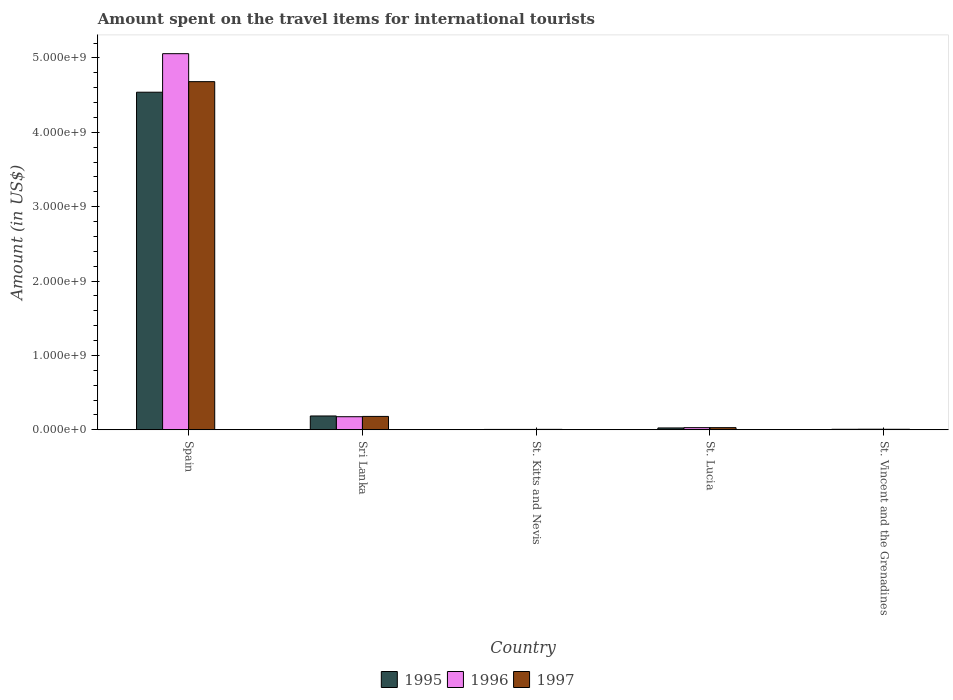How many different coloured bars are there?
Your response must be concise. 3. How many groups of bars are there?
Give a very brief answer. 5. How many bars are there on the 2nd tick from the left?
Make the answer very short. 3. How many bars are there on the 5th tick from the right?
Your response must be concise. 3. What is the label of the 5th group of bars from the left?
Your answer should be very brief. St. Vincent and the Grenadines. In how many cases, is the number of bars for a given country not equal to the number of legend labels?
Provide a short and direct response. 0. What is the amount spent on the travel items for international tourists in 1997 in Spain?
Provide a short and direct response. 4.68e+09. Across all countries, what is the maximum amount spent on the travel items for international tourists in 1995?
Provide a succinct answer. 4.54e+09. Across all countries, what is the minimum amount spent on the travel items for international tourists in 1997?
Your response must be concise. 6.00e+06. In which country was the amount spent on the travel items for international tourists in 1997 maximum?
Your answer should be compact. Spain. In which country was the amount spent on the travel items for international tourists in 1997 minimum?
Your answer should be very brief. St. Kitts and Nevis. What is the total amount spent on the travel items for international tourists in 1997 in the graph?
Ensure brevity in your answer.  4.90e+09. What is the difference between the amount spent on the travel items for international tourists in 1996 in St. Lucia and that in St. Vincent and the Grenadines?
Make the answer very short. 2.10e+07. What is the difference between the amount spent on the travel items for international tourists in 1995 in St. Lucia and the amount spent on the travel items for international tourists in 1996 in Spain?
Provide a short and direct response. -5.03e+09. What is the average amount spent on the travel items for international tourists in 1996 per country?
Your response must be concise. 1.06e+09. What is the difference between the amount spent on the travel items for international tourists of/in 1996 and amount spent on the travel items for international tourists of/in 1995 in Sri Lanka?
Your answer should be very brief. -1.00e+07. What is the ratio of the amount spent on the travel items for international tourists in 1997 in Sri Lanka to that in St. Lucia?
Your answer should be compact. 6.21. What is the difference between the highest and the second highest amount spent on the travel items for international tourists in 1997?
Offer a terse response. 4.50e+09. What is the difference between the highest and the lowest amount spent on the travel items for international tourists in 1996?
Provide a short and direct response. 5.05e+09. In how many countries, is the amount spent on the travel items for international tourists in 1996 greater than the average amount spent on the travel items for international tourists in 1996 taken over all countries?
Keep it short and to the point. 1. Is the sum of the amount spent on the travel items for international tourists in 1997 in St. Lucia and St. Vincent and the Grenadines greater than the maximum amount spent on the travel items for international tourists in 1995 across all countries?
Offer a terse response. No. Are all the bars in the graph horizontal?
Ensure brevity in your answer.  No. How many countries are there in the graph?
Provide a short and direct response. 5. Are the values on the major ticks of Y-axis written in scientific E-notation?
Ensure brevity in your answer.  Yes. Does the graph contain any zero values?
Your answer should be compact. No. How many legend labels are there?
Offer a very short reply. 3. What is the title of the graph?
Give a very brief answer. Amount spent on the travel items for international tourists. Does "1965" appear as one of the legend labels in the graph?
Make the answer very short. No. What is the Amount (in US$) of 1995 in Spain?
Offer a terse response. 4.54e+09. What is the Amount (in US$) of 1996 in Spain?
Provide a succinct answer. 5.06e+09. What is the Amount (in US$) in 1997 in Spain?
Your response must be concise. 4.68e+09. What is the Amount (in US$) in 1995 in Sri Lanka?
Your response must be concise. 1.86e+08. What is the Amount (in US$) of 1996 in Sri Lanka?
Offer a very short reply. 1.76e+08. What is the Amount (in US$) in 1997 in Sri Lanka?
Keep it short and to the point. 1.80e+08. What is the Amount (in US$) of 1995 in St. Kitts and Nevis?
Provide a short and direct response. 5.00e+06. What is the Amount (in US$) in 1996 in St. Kitts and Nevis?
Your response must be concise. 5.00e+06. What is the Amount (in US$) in 1995 in St. Lucia?
Your response must be concise. 2.50e+07. What is the Amount (in US$) of 1996 in St. Lucia?
Provide a succinct answer. 2.90e+07. What is the Amount (in US$) in 1997 in St. Lucia?
Make the answer very short. 2.90e+07. What is the Amount (in US$) in 1995 in St. Vincent and the Grenadines?
Your answer should be very brief. 7.00e+06. What is the Amount (in US$) in 1997 in St. Vincent and the Grenadines?
Offer a very short reply. 7.00e+06. Across all countries, what is the maximum Amount (in US$) in 1995?
Provide a succinct answer. 4.54e+09. Across all countries, what is the maximum Amount (in US$) in 1996?
Provide a succinct answer. 5.06e+09. Across all countries, what is the maximum Amount (in US$) of 1997?
Offer a terse response. 4.68e+09. Across all countries, what is the minimum Amount (in US$) of 1995?
Offer a terse response. 5.00e+06. Across all countries, what is the minimum Amount (in US$) in 1996?
Offer a terse response. 5.00e+06. Across all countries, what is the minimum Amount (in US$) of 1997?
Your response must be concise. 6.00e+06. What is the total Amount (in US$) of 1995 in the graph?
Ensure brevity in your answer.  4.76e+09. What is the total Amount (in US$) in 1996 in the graph?
Provide a short and direct response. 5.28e+09. What is the total Amount (in US$) of 1997 in the graph?
Offer a very short reply. 4.90e+09. What is the difference between the Amount (in US$) in 1995 in Spain and that in Sri Lanka?
Provide a succinct answer. 4.35e+09. What is the difference between the Amount (in US$) of 1996 in Spain and that in Sri Lanka?
Provide a succinct answer. 4.88e+09. What is the difference between the Amount (in US$) of 1997 in Spain and that in Sri Lanka?
Give a very brief answer. 4.50e+09. What is the difference between the Amount (in US$) of 1995 in Spain and that in St. Kitts and Nevis?
Give a very brief answer. 4.53e+09. What is the difference between the Amount (in US$) of 1996 in Spain and that in St. Kitts and Nevis?
Ensure brevity in your answer.  5.05e+09. What is the difference between the Amount (in US$) of 1997 in Spain and that in St. Kitts and Nevis?
Provide a short and direct response. 4.68e+09. What is the difference between the Amount (in US$) in 1995 in Spain and that in St. Lucia?
Provide a short and direct response. 4.51e+09. What is the difference between the Amount (in US$) of 1996 in Spain and that in St. Lucia?
Keep it short and to the point. 5.03e+09. What is the difference between the Amount (in US$) of 1997 in Spain and that in St. Lucia?
Your answer should be compact. 4.65e+09. What is the difference between the Amount (in US$) in 1995 in Spain and that in St. Vincent and the Grenadines?
Your answer should be compact. 4.53e+09. What is the difference between the Amount (in US$) of 1996 in Spain and that in St. Vincent and the Grenadines?
Provide a succinct answer. 5.05e+09. What is the difference between the Amount (in US$) of 1997 in Spain and that in St. Vincent and the Grenadines?
Your answer should be very brief. 4.67e+09. What is the difference between the Amount (in US$) of 1995 in Sri Lanka and that in St. Kitts and Nevis?
Ensure brevity in your answer.  1.81e+08. What is the difference between the Amount (in US$) in 1996 in Sri Lanka and that in St. Kitts and Nevis?
Make the answer very short. 1.71e+08. What is the difference between the Amount (in US$) in 1997 in Sri Lanka and that in St. Kitts and Nevis?
Make the answer very short. 1.74e+08. What is the difference between the Amount (in US$) of 1995 in Sri Lanka and that in St. Lucia?
Your answer should be very brief. 1.61e+08. What is the difference between the Amount (in US$) of 1996 in Sri Lanka and that in St. Lucia?
Your answer should be very brief. 1.47e+08. What is the difference between the Amount (in US$) of 1997 in Sri Lanka and that in St. Lucia?
Provide a short and direct response. 1.51e+08. What is the difference between the Amount (in US$) of 1995 in Sri Lanka and that in St. Vincent and the Grenadines?
Your response must be concise. 1.79e+08. What is the difference between the Amount (in US$) in 1996 in Sri Lanka and that in St. Vincent and the Grenadines?
Your answer should be compact. 1.68e+08. What is the difference between the Amount (in US$) of 1997 in Sri Lanka and that in St. Vincent and the Grenadines?
Ensure brevity in your answer.  1.73e+08. What is the difference between the Amount (in US$) in 1995 in St. Kitts and Nevis and that in St. Lucia?
Offer a very short reply. -2.00e+07. What is the difference between the Amount (in US$) of 1996 in St. Kitts and Nevis and that in St. Lucia?
Your answer should be very brief. -2.40e+07. What is the difference between the Amount (in US$) in 1997 in St. Kitts and Nevis and that in St. Lucia?
Provide a short and direct response. -2.30e+07. What is the difference between the Amount (in US$) in 1996 in St. Kitts and Nevis and that in St. Vincent and the Grenadines?
Your response must be concise. -3.00e+06. What is the difference between the Amount (in US$) of 1997 in St. Kitts and Nevis and that in St. Vincent and the Grenadines?
Offer a terse response. -1.00e+06. What is the difference between the Amount (in US$) of 1995 in St. Lucia and that in St. Vincent and the Grenadines?
Provide a succinct answer. 1.80e+07. What is the difference between the Amount (in US$) in 1996 in St. Lucia and that in St. Vincent and the Grenadines?
Keep it short and to the point. 2.10e+07. What is the difference between the Amount (in US$) of 1997 in St. Lucia and that in St. Vincent and the Grenadines?
Offer a terse response. 2.20e+07. What is the difference between the Amount (in US$) of 1995 in Spain and the Amount (in US$) of 1996 in Sri Lanka?
Your answer should be very brief. 4.36e+09. What is the difference between the Amount (in US$) of 1995 in Spain and the Amount (in US$) of 1997 in Sri Lanka?
Make the answer very short. 4.36e+09. What is the difference between the Amount (in US$) in 1996 in Spain and the Amount (in US$) in 1997 in Sri Lanka?
Your answer should be very brief. 4.88e+09. What is the difference between the Amount (in US$) in 1995 in Spain and the Amount (in US$) in 1996 in St. Kitts and Nevis?
Provide a succinct answer. 4.53e+09. What is the difference between the Amount (in US$) of 1995 in Spain and the Amount (in US$) of 1997 in St. Kitts and Nevis?
Ensure brevity in your answer.  4.53e+09. What is the difference between the Amount (in US$) in 1996 in Spain and the Amount (in US$) in 1997 in St. Kitts and Nevis?
Offer a terse response. 5.05e+09. What is the difference between the Amount (in US$) in 1995 in Spain and the Amount (in US$) in 1996 in St. Lucia?
Make the answer very short. 4.51e+09. What is the difference between the Amount (in US$) of 1995 in Spain and the Amount (in US$) of 1997 in St. Lucia?
Ensure brevity in your answer.  4.51e+09. What is the difference between the Amount (in US$) in 1996 in Spain and the Amount (in US$) in 1997 in St. Lucia?
Make the answer very short. 5.03e+09. What is the difference between the Amount (in US$) of 1995 in Spain and the Amount (in US$) of 1996 in St. Vincent and the Grenadines?
Your answer should be very brief. 4.53e+09. What is the difference between the Amount (in US$) in 1995 in Spain and the Amount (in US$) in 1997 in St. Vincent and the Grenadines?
Offer a very short reply. 4.53e+09. What is the difference between the Amount (in US$) in 1996 in Spain and the Amount (in US$) in 1997 in St. Vincent and the Grenadines?
Your response must be concise. 5.05e+09. What is the difference between the Amount (in US$) in 1995 in Sri Lanka and the Amount (in US$) in 1996 in St. Kitts and Nevis?
Offer a terse response. 1.81e+08. What is the difference between the Amount (in US$) in 1995 in Sri Lanka and the Amount (in US$) in 1997 in St. Kitts and Nevis?
Ensure brevity in your answer.  1.80e+08. What is the difference between the Amount (in US$) of 1996 in Sri Lanka and the Amount (in US$) of 1997 in St. Kitts and Nevis?
Your answer should be very brief. 1.70e+08. What is the difference between the Amount (in US$) of 1995 in Sri Lanka and the Amount (in US$) of 1996 in St. Lucia?
Your answer should be compact. 1.57e+08. What is the difference between the Amount (in US$) of 1995 in Sri Lanka and the Amount (in US$) of 1997 in St. Lucia?
Give a very brief answer. 1.57e+08. What is the difference between the Amount (in US$) of 1996 in Sri Lanka and the Amount (in US$) of 1997 in St. Lucia?
Make the answer very short. 1.47e+08. What is the difference between the Amount (in US$) of 1995 in Sri Lanka and the Amount (in US$) of 1996 in St. Vincent and the Grenadines?
Your answer should be very brief. 1.78e+08. What is the difference between the Amount (in US$) of 1995 in Sri Lanka and the Amount (in US$) of 1997 in St. Vincent and the Grenadines?
Make the answer very short. 1.79e+08. What is the difference between the Amount (in US$) in 1996 in Sri Lanka and the Amount (in US$) in 1997 in St. Vincent and the Grenadines?
Offer a very short reply. 1.69e+08. What is the difference between the Amount (in US$) in 1995 in St. Kitts and Nevis and the Amount (in US$) in 1996 in St. Lucia?
Provide a succinct answer. -2.40e+07. What is the difference between the Amount (in US$) of 1995 in St. Kitts and Nevis and the Amount (in US$) of 1997 in St. Lucia?
Offer a very short reply. -2.40e+07. What is the difference between the Amount (in US$) of 1996 in St. Kitts and Nevis and the Amount (in US$) of 1997 in St. Lucia?
Your answer should be compact. -2.40e+07. What is the difference between the Amount (in US$) of 1995 in St. Lucia and the Amount (in US$) of 1996 in St. Vincent and the Grenadines?
Keep it short and to the point. 1.70e+07. What is the difference between the Amount (in US$) of 1995 in St. Lucia and the Amount (in US$) of 1997 in St. Vincent and the Grenadines?
Your answer should be very brief. 1.80e+07. What is the difference between the Amount (in US$) in 1996 in St. Lucia and the Amount (in US$) in 1997 in St. Vincent and the Grenadines?
Your answer should be compact. 2.20e+07. What is the average Amount (in US$) of 1995 per country?
Your answer should be compact. 9.52e+08. What is the average Amount (in US$) of 1996 per country?
Offer a very short reply. 1.06e+09. What is the average Amount (in US$) of 1997 per country?
Provide a short and direct response. 9.81e+08. What is the difference between the Amount (in US$) in 1995 and Amount (in US$) in 1996 in Spain?
Provide a succinct answer. -5.18e+08. What is the difference between the Amount (in US$) of 1995 and Amount (in US$) of 1997 in Spain?
Your answer should be very brief. -1.42e+08. What is the difference between the Amount (in US$) of 1996 and Amount (in US$) of 1997 in Spain?
Your answer should be compact. 3.76e+08. What is the difference between the Amount (in US$) in 1995 and Amount (in US$) in 1996 in Sri Lanka?
Ensure brevity in your answer.  1.00e+07. What is the difference between the Amount (in US$) in 1995 and Amount (in US$) in 1997 in Sri Lanka?
Your response must be concise. 6.00e+06. What is the difference between the Amount (in US$) in 1996 and Amount (in US$) in 1997 in St. Kitts and Nevis?
Give a very brief answer. -1.00e+06. What is the ratio of the Amount (in US$) of 1995 in Spain to that in Sri Lanka?
Offer a terse response. 24.4. What is the ratio of the Amount (in US$) of 1996 in Spain to that in Sri Lanka?
Make the answer very short. 28.73. What is the ratio of the Amount (in US$) of 1997 in Spain to that in Sri Lanka?
Give a very brief answer. 26.01. What is the ratio of the Amount (in US$) of 1995 in Spain to that in St. Kitts and Nevis?
Make the answer very short. 907.8. What is the ratio of the Amount (in US$) of 1996 in Spain to that in St. Kitts and Nevis?
Provide a short and direct response. 1011.4. What is the ratio of the Amount (in US$) in 1997 in Spain to that in St. Kitts and Nevis?
Your answer should be compact. 780.17. What is the ratio of the Amount (in US$) of 1995 in Spain to that in St. Lucia?
Make the answer very short. 181.56. What is the ratio of the Amount (in US$) in 1996 in Spain to that in St. Lucia?
Offer a terse response. 174.38. What is the ratio of the Amount (in US$) in 1997 in Spain to that in St. Lucia?
Keep it short and to the point. 161.41. What is the ratio of the Amount (in US$) in 1995 in Spain to that in St. Vincent and the Grenadines?
Ensure brevity in your answer.  648.43. What is the ratio of the Amount (in US$) in 1996 in Spain to that in St. Vincent and the Grenadines?
Your answer should be very brief. 632.12. What is the ratio of the Amount (in US$) of 1997 in Spain to that in St. Vincent and the Grenadines?
Offer a very short reply. 668.71. What is the ratio of the Amount (in US$) in 1995 in Sri Lanka to that in St. Kitts and Nevis?
Your answer should be very brief. 37.2. What is the ratio of the Amount (in US$) of 1996 in Sri Lanka to that in St. Kitts and Nevis?
Your answer should be very brief. 35.2. What is the ratio of the Amount (in US$) in 1997 in Sri Lanka to that in St. Kitts and Nevis?
Make the answer very short. 30. What is the ratio of the Amount (in US$) of 1995 in Sri Lanka to that in St. Lucia?
Ensure brevity in your answer.  7.44. What is the ratio of the Amount (in US$) of 1996 in Sri Lanka to that in St. Lucia?
Your answer should be very brief. 6.07. What is the ratio of the Amount (in US$) in 1997 in Sri Lanka to that in St. Lucia?
Offer a terse response. 6.21. What is the ratio of the Amount (in US$) in 1995 in Sri Lanka to that in St. Vincent and the Grenadines?
Keep it short and to the point. 26.57. What is the ratio of the Amount (in US$) of 1996 in Sri Lanka to that in St. Vincent and the Grenadines?
Make the answer very short. 22. What is the ratio of the Amount (in US$) of 1997 in Sri Lanka to that in St. Vincent and the Grenadines?
Your answer should be compact. 25.71. What is the ratio of the Amount (in US$) of 1995 in St. Kitts and Nevis to that in St. Lucia?
Keep it short and to the point. 0.2. What is the ratio of the Amount (in US$) of 1996 in St. Kitts and Nevis to that in St. Lucia?
Your response must be concise. 0.17. What is the ratio of the Amount (in US$) in 1997 in St. Kitts and Nevis to that in St. Lucia?
Give a very brief answer. 0.21. What is the ratio of the Amount (in US$) in 1995 in St. Kitts and Nevis to that in St. Vincent and the Grenadines?
Make the answer very short. 0.71. What is the ratio of the Amount (in US$) of 1995 in St. Lucia to that in St. Vincent and the Grenadines?
Your answer should be compact. 3.57. What is the ratio of the Amount (in US$) of 1996 in St. Lucia to that in St. Vincent and the Grenadines?
Your answer should be very brief. 3.62. What is the ratio of the Amount (in US$) in 1997 in St. Lucia to that in St. Vincent and the Grenadines?
Provide a short and direct response. 4.14. What is the difference between the highest and the second highest Amount (in US$) in 1995?
Offer a very short reply. 4.35e+09. What is the difference between the highest and the second highest Amount (in US$) of 1996?
Make the answer very short. 4.88e+09. What is the difference between the highest and the second highest Amount (in US$) in 1997?
Keep it short and to the point. 4.50e+09. What is the difference between the highest and the lowest Amount (in US$) in 1995?
Your answer should be compact. 4.53e+09. What is the difference between the highest and the lowest Amount (in US$) of 1996?
Make the answer very short. 5.05e+09. What is the difference between the highest and the lowest Amount (in US$) of 1997?
Offer a terse response. 4.68e+09. 